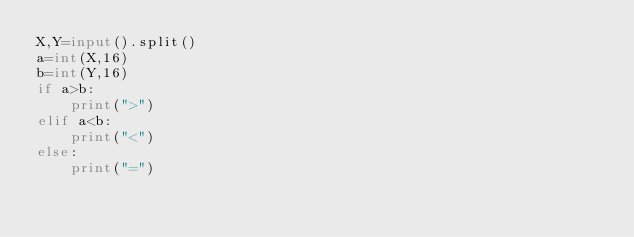<code> <loc_0><loc_0><loc_500><loc_500><_Python_>X,Y=input().split()
a=int(X,16)
b=int(Y,16)
if a>b:
    print(">")
elif a<b:
    print("<")
else:
    print("=")</code> 